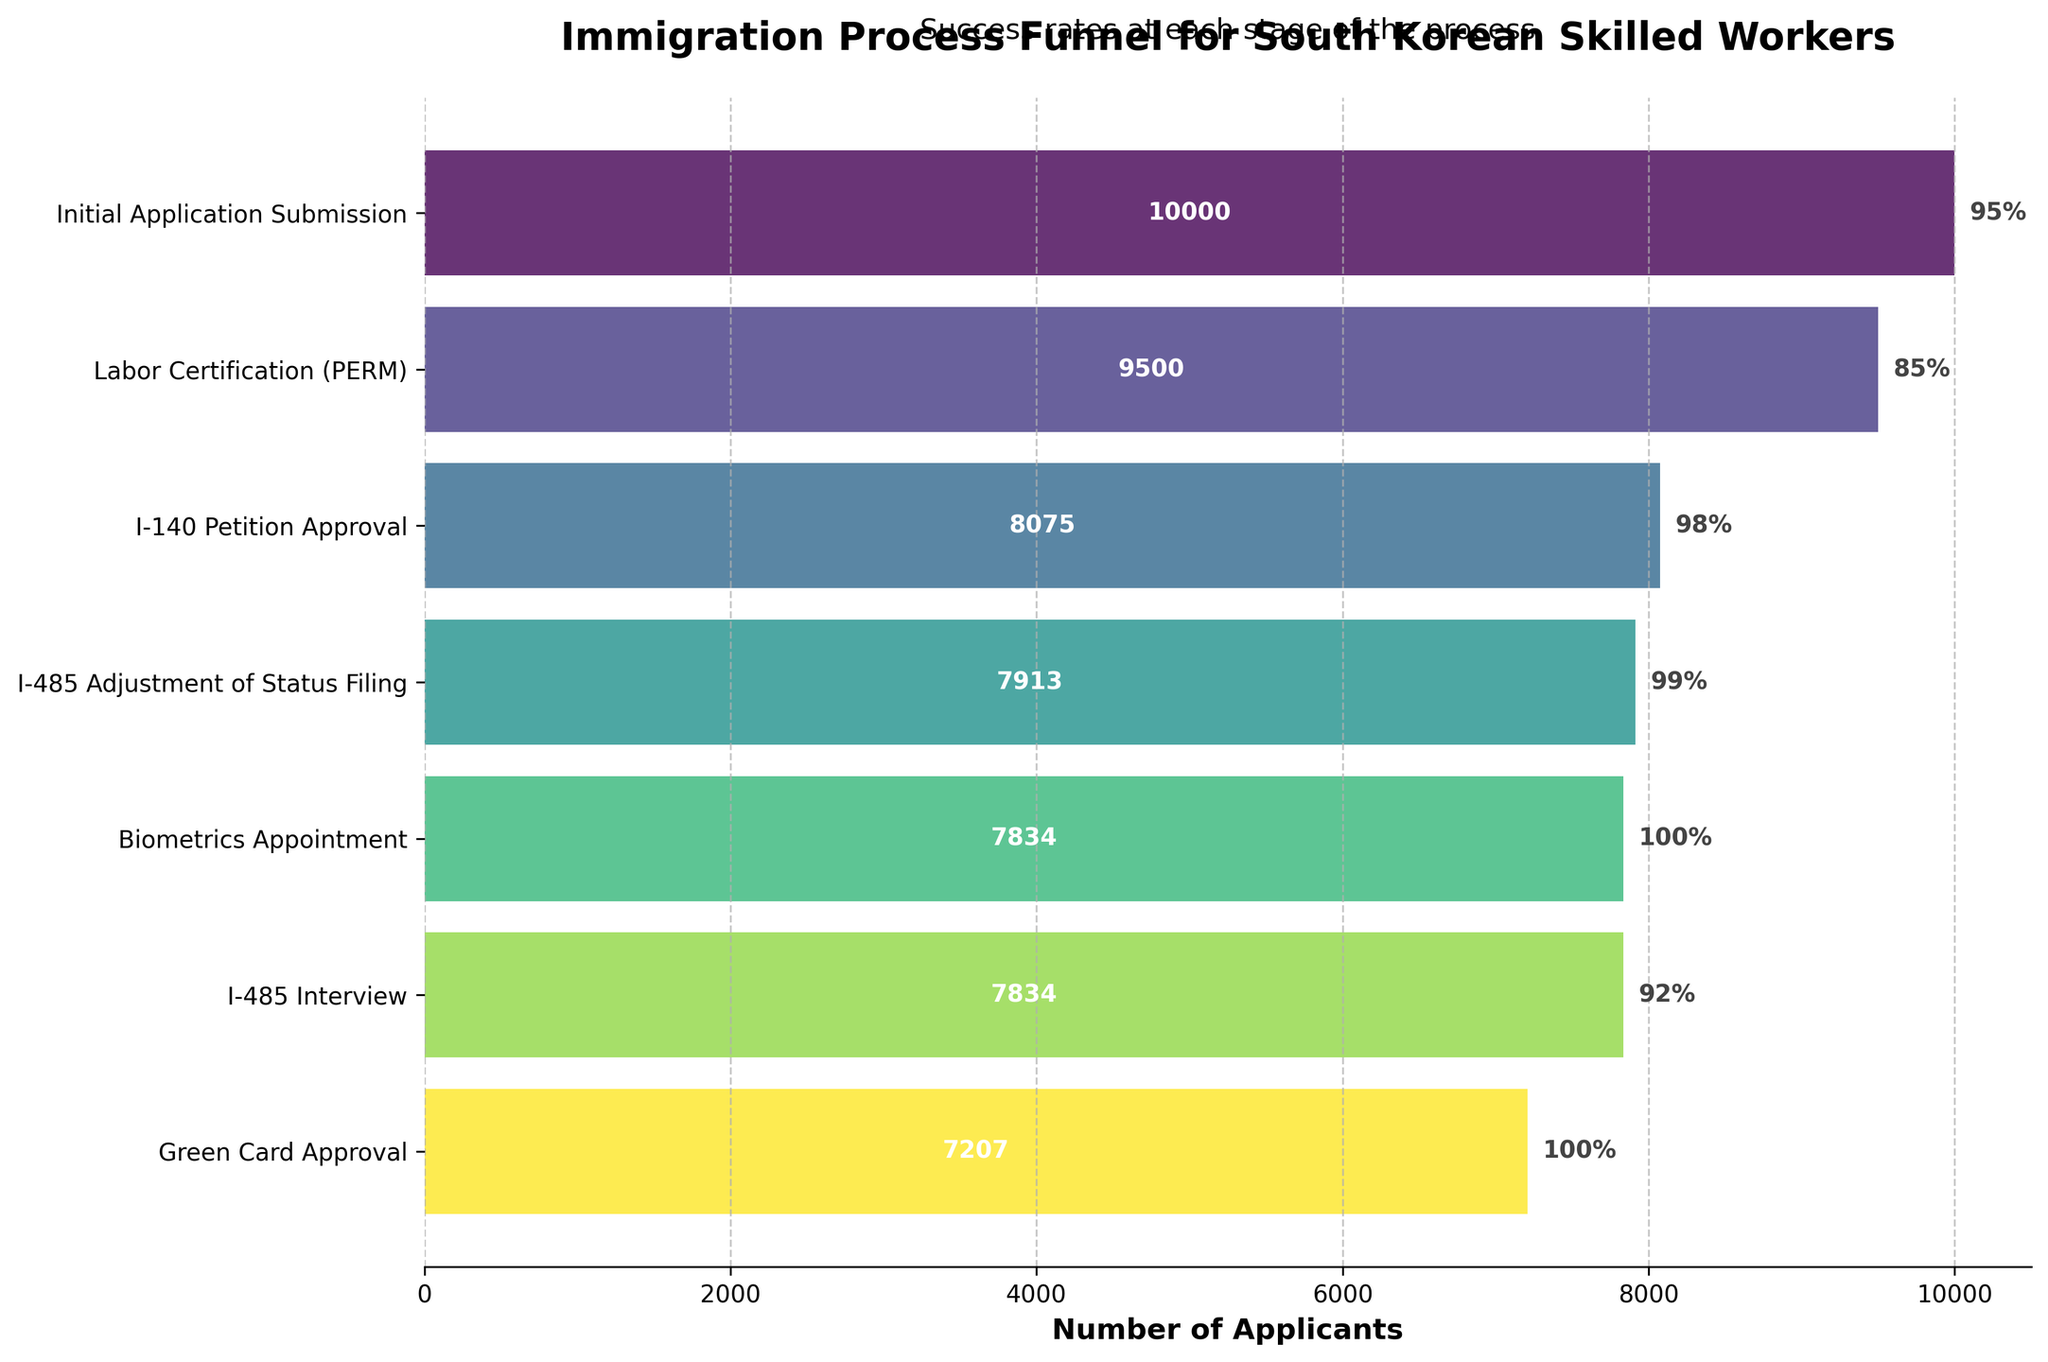What's the title of the chart? The title is prominently displayed at the top of the chart. It provides context about what the chart represents, focusing on a specific subject related to immigration.
Answer: Immigration Process Funnel for South Korean Skilled Workers What is the success rate at the Labor Certification (PERM) stage? The success rate at each stage is indicated next to the corresponding bar. For the Labor Certification (PERM) stage, this information can be found to the right of the bar.
Answer: 85% How many applicants successfully passed the I-140 Petition Approval stage? The number of applicants at each stage is displayed inside the bars. For the I-140 Petition Approval stage, this number can be found within the relevant bar.
Answer: 8075 Which stage had the highest drop in the number of applicants? To find the stage with the highest drop in applicants, subtract the number of applicants at each successive stage and identify the largest difference. The largest drop occurs between the I-485 Interview and the Green Card Approval stages.
Answer: I-485 Interview to Green Card Approval What percentage of applicants made it to the Biometrics Appointment stage compared to the initial number of applicants? Calculate the percentage by dividing the number of applicants at the Biometrics Appointment stage by the initial number of applicants and then multiply by 100. The number of applicants at the Biometrics Appointment stage is 7834, and the initial number is 10000. (7834 / 10000) * 100 = 78.34%.
Answer: 78.34% At which stage do applicants experience the first 100% success rate? Identify the first stage where the success rate shown on the chart is 100%. This rate is indicated on the right of each bar.
Answer: Biometrics Appointment What is the difference in the number of applicants between the Labor Certification (PERM) and I-485 Adjustment of Status Filing stages? To find the difference, subtract the number of applicants at the I-485 Adjustment of Status Filing stage from the number of applicants at the Labor Certification (PERM) stage. 9500 - 7913 = 1587.
Answer: 1587 Which stage comes after the I-485 Adjustment of Status Filing stage? Look at the order of stages in the funnel chart to determine which stage immediately follows the I-485 Adjustment of Status Filing.
Answer: Biometrics Appointment What is the second highest success rate shown on the chart? Identify the success rates shown for each stage and determine which one is second highest. The rates are 95%, 85%, 98%, 99%, 100%, 92%, and 100%. The second highest is 99%.
Answer: 99% 